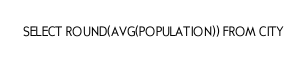Convert code to text. <code><loc_0><loc_0><loc_500><loc_500><_SQL_>SELECT ROUND(AVG(POPULATION)) FROM CITY</code> 